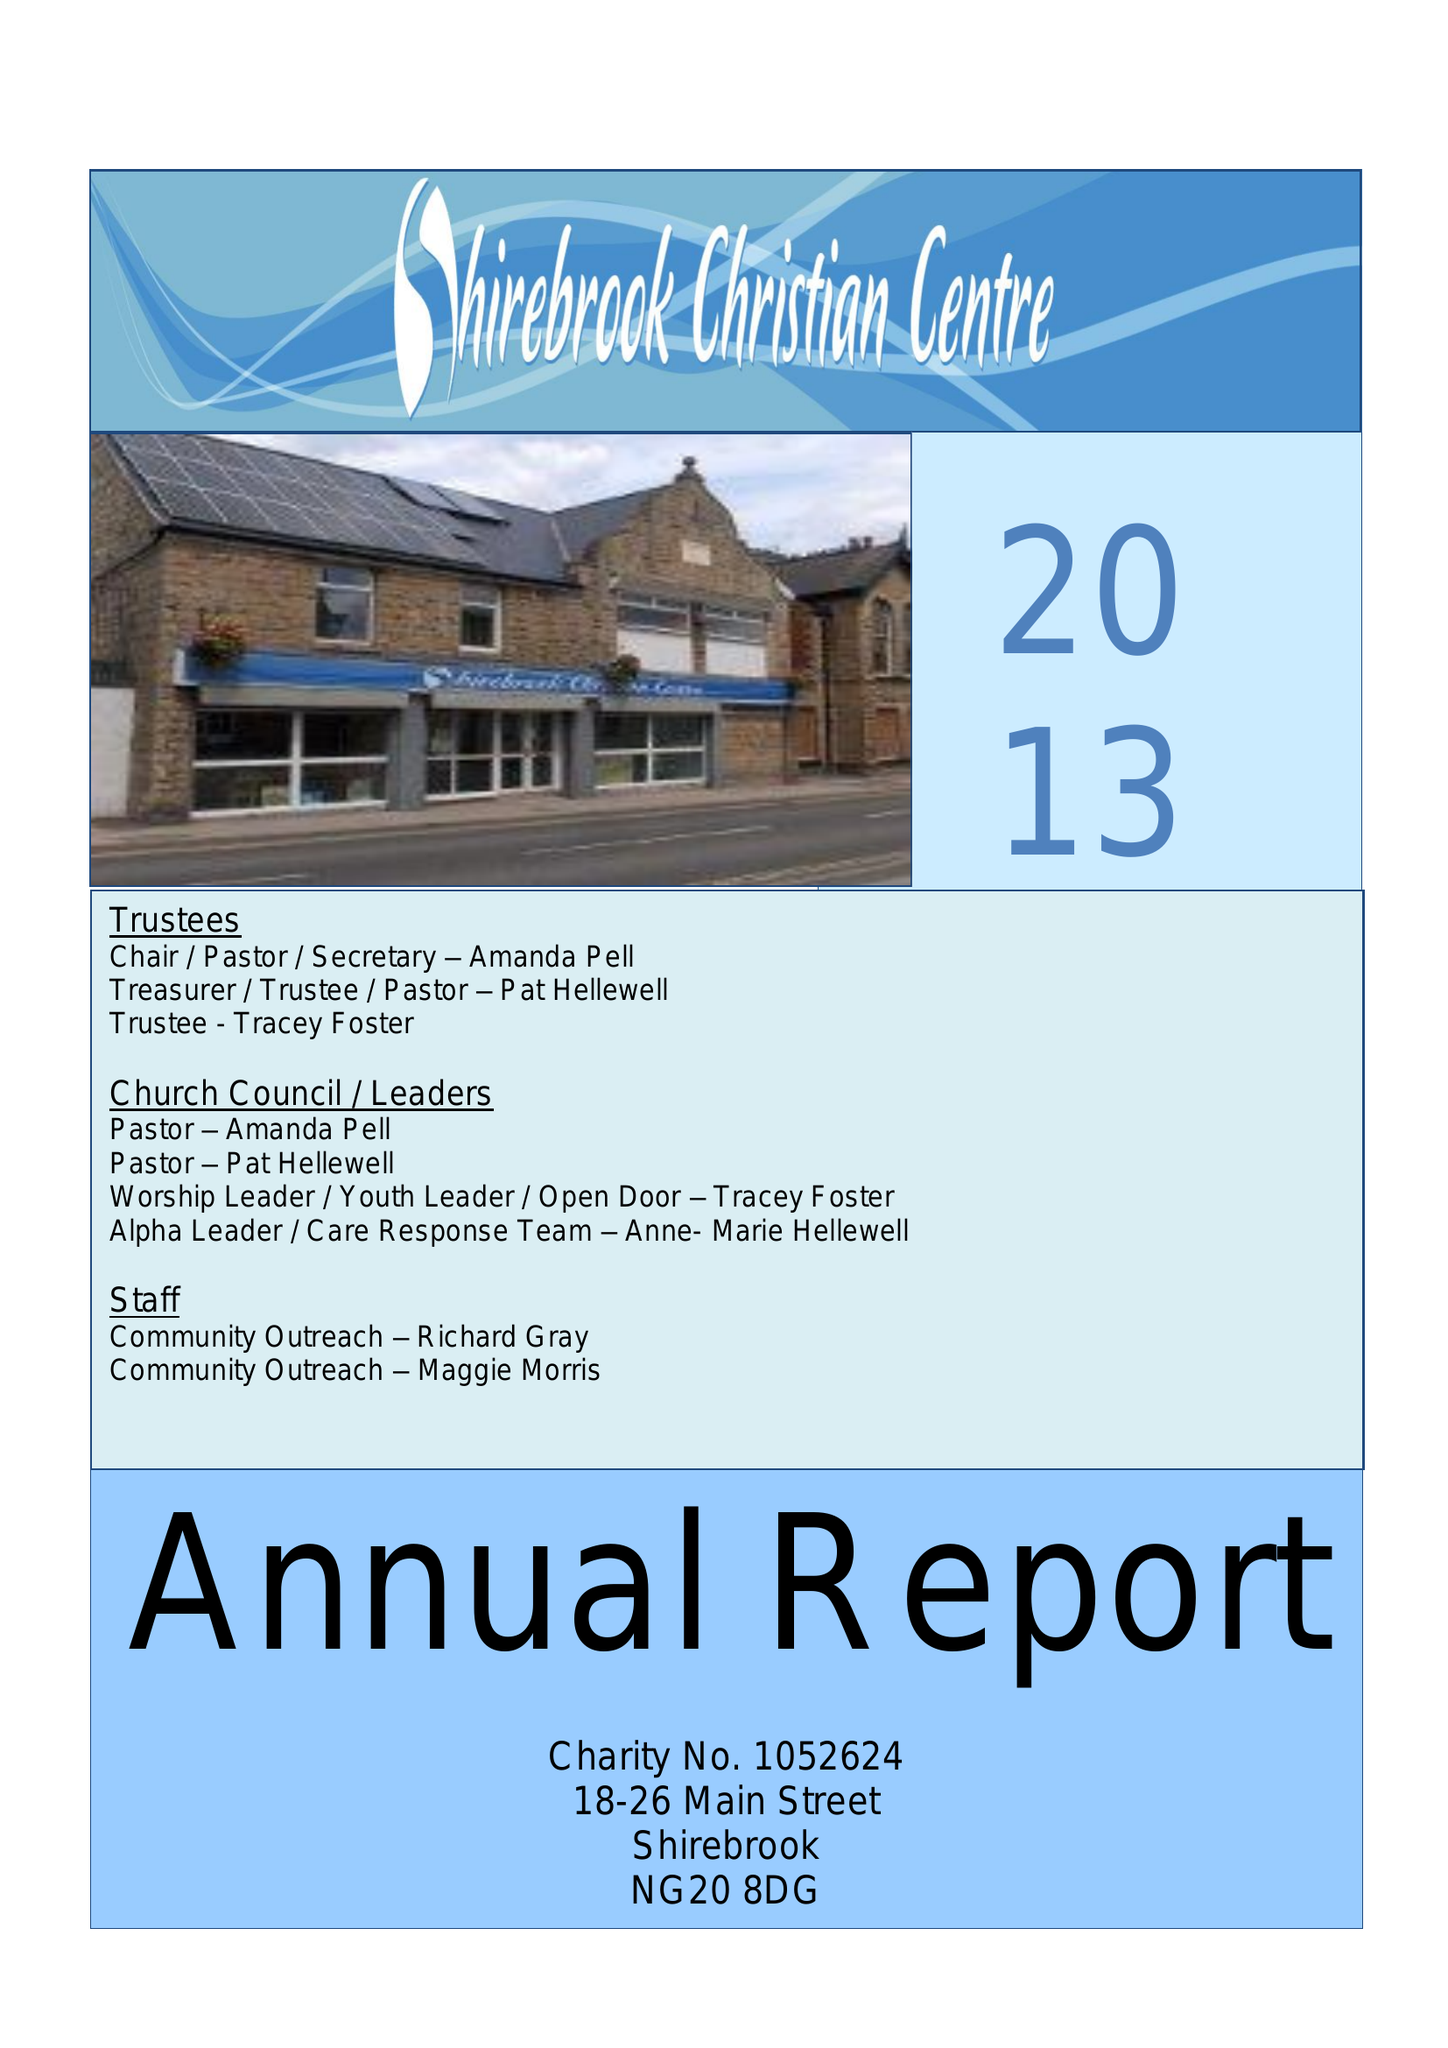What is the value for the spending_annually_in_british_pounds?
Answer the question using a single word or phrase. 43696.00 